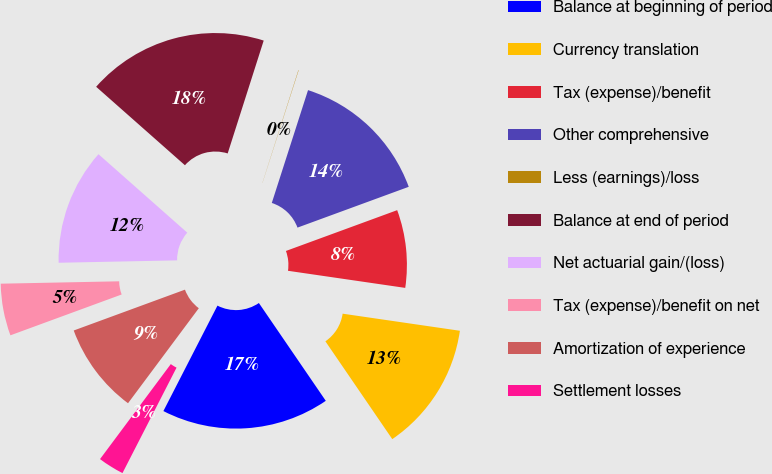Convert chart to OTSL. <chart><loc_0><loc_0><loc_500><loc_500><pie_chart><fcel>Balance at beginning of period<fcel>Currency translation<fcel>Tax (expense)/benefit<fcel>Other comprehensive<fcel>Less (earnings)/loss<fcel>Balance at end of period<fcel>Net actuarial gain/(loss)<fcel>Tax (expense)/benefit on net<fcel>Amortization of experience<fcel>Settlement losses<nl><fcel>17.09%<fcel>13.15%<fcel>7.9%<fcel>14.46%<fcel>0.03%<fcel>18.4%<fcel>11.84%<fcel>5.28%<fcel>9.21%<fcel>2.65%<nl></chart> 